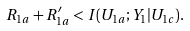Convert formula to latex. <formula><loc_0><loc_0><loc_500><loc_500>R _ { 1 a } + R ^ { \prime } _ { 1 a } < I ( U _ { 1 a } ; Y _ { 1 } | U _ { 1 c } ) .</formula> 